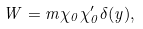<formula> <loc_0><loc_0><loc_500><loc_500>W = m \chi _ { 0 } \chi ^ { \prime } _ { 0 } \delta ( y ) ,</formula> 